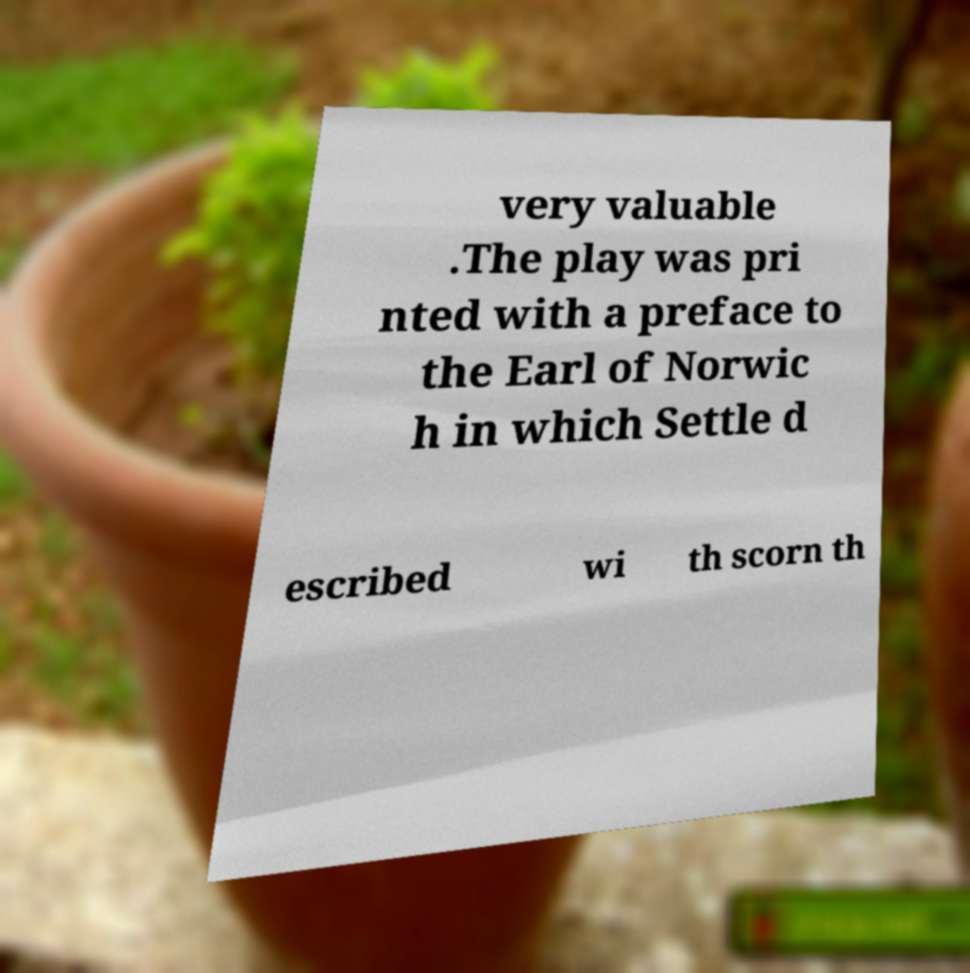Could you extract and type out the text from this image? very valuable .The play was pri nted with a preface to the Earl of Norwic h in which Settle d escribed wi th scorn th 